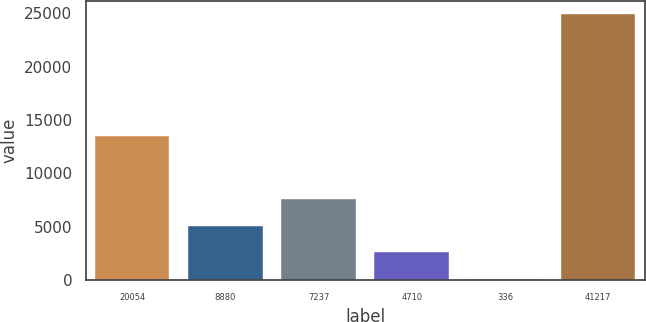Convert chart. <chart><loc_0><loc_0><loc_500><loc_500><bar_chart><fcel>20054<fcel>8880<fcel>7237<fcel>4710<fcel>336<fcel>41217<nl><fcel>13539<fcel>5085.8<fcel>7562.7<fcel>2608.9<fcel>132<fcel>24901<nl></chart> 